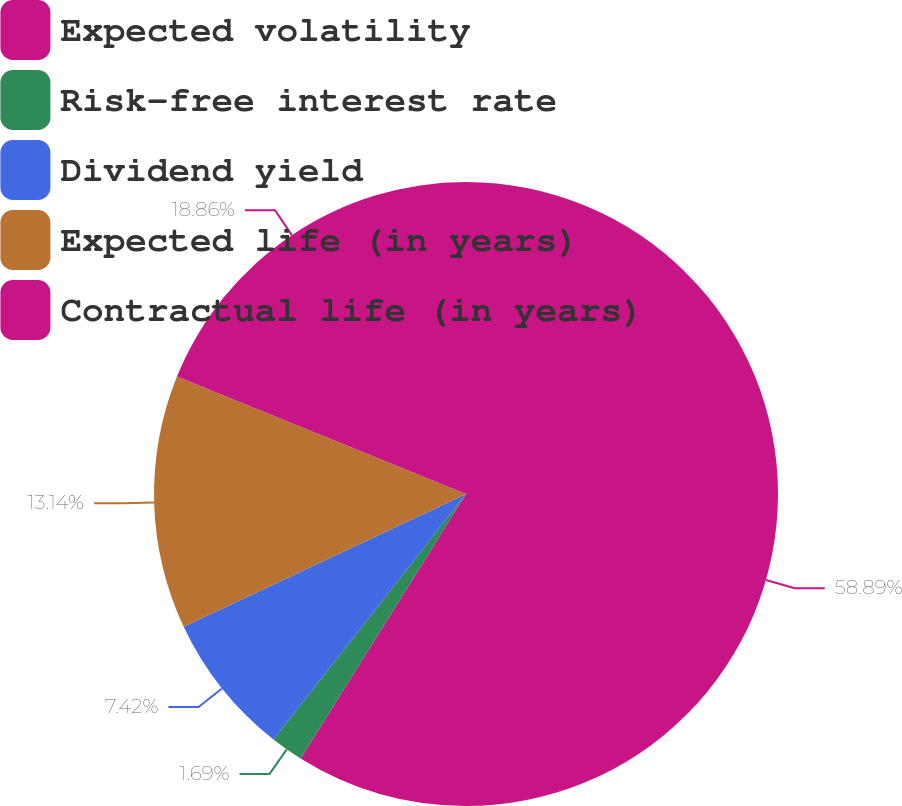Convert chart to OTSL. <chart><loc_0><loc_0><loc_500><loc_500><pie_chart><fcel>Expected volatility<fcel>Risk-free interest rate<fcel>Dividend yield<fcel>Expected life (in years)<fcel>Contractual life (in years)<nl><fcel>58.9%<fcel>1.69%<fcel>7.42%<fcel>13.14%<fcel>18.86%<nl></chart> 